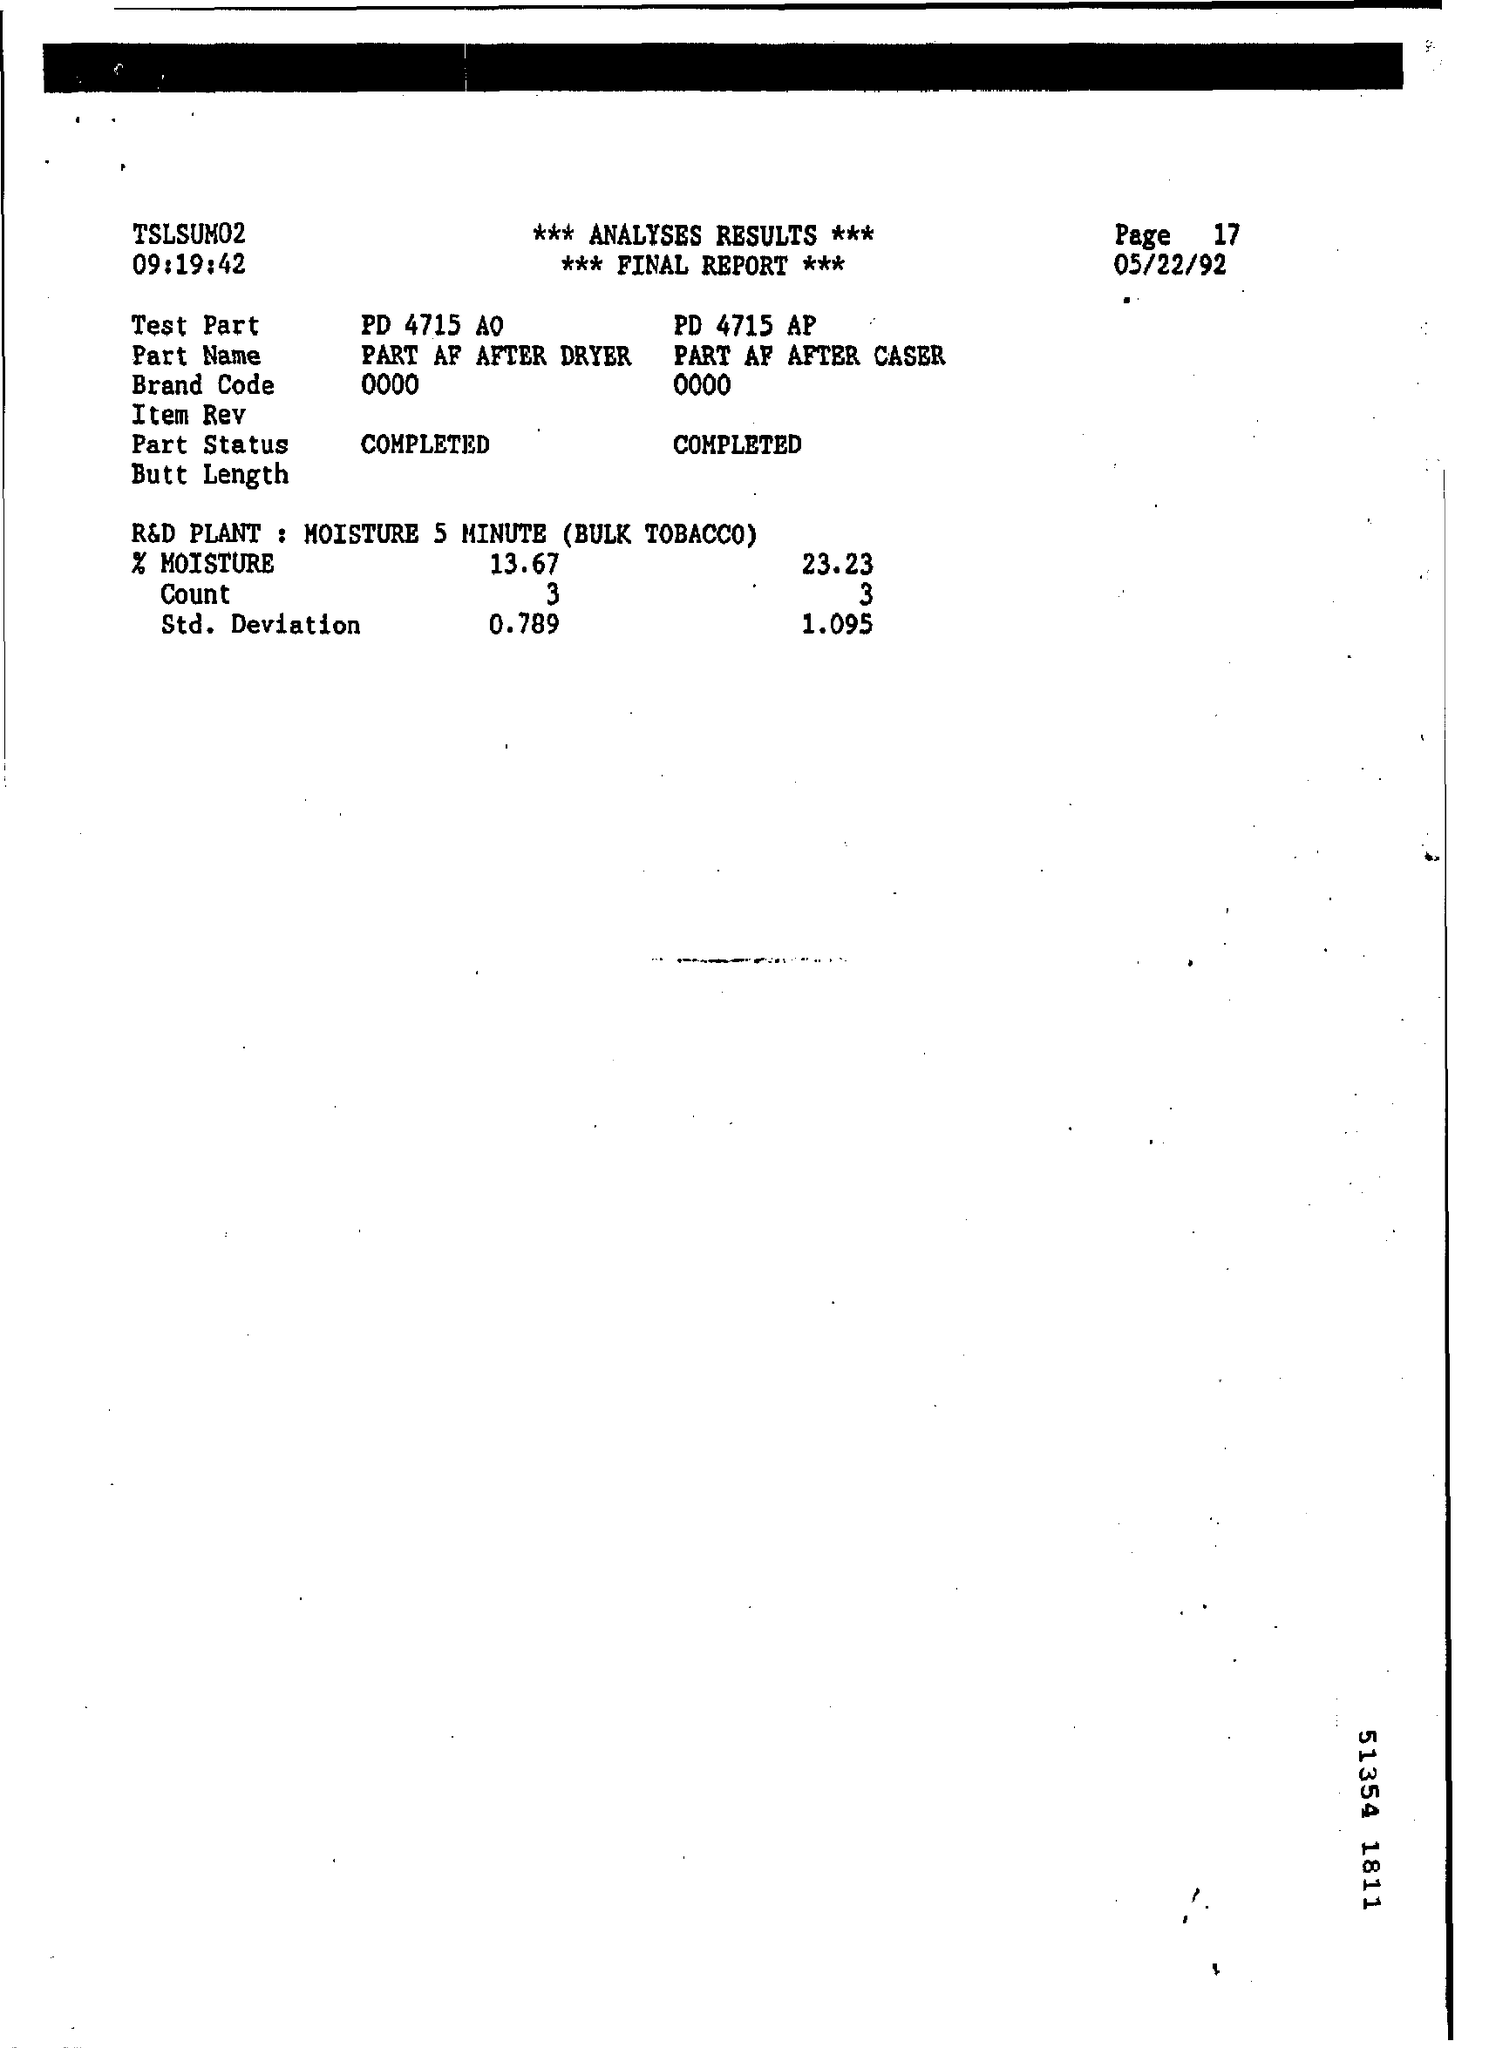Give some essential details in this illustration. The band code is 0000.. The page number is 17. The memorandum was dated on May 22, 1992. 